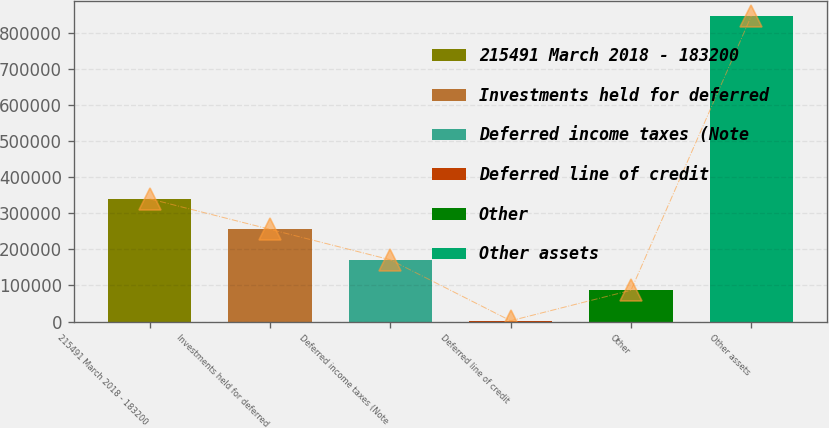<chart> <loc_0><loc_0><loc_500><loc_500><bar_chart><fcel>215491 March 2018 - 183200<fcel>Investments held for deferred<fcel>Deferred income taxes (Note<fcel>Deferred line of credit<fcel>Other<fcel>Other assets<nl><fcel>340032<fcel>255554<fcel>171077<fcel>2121<fcel>86598.8<fcel>846899<nl></chart> 